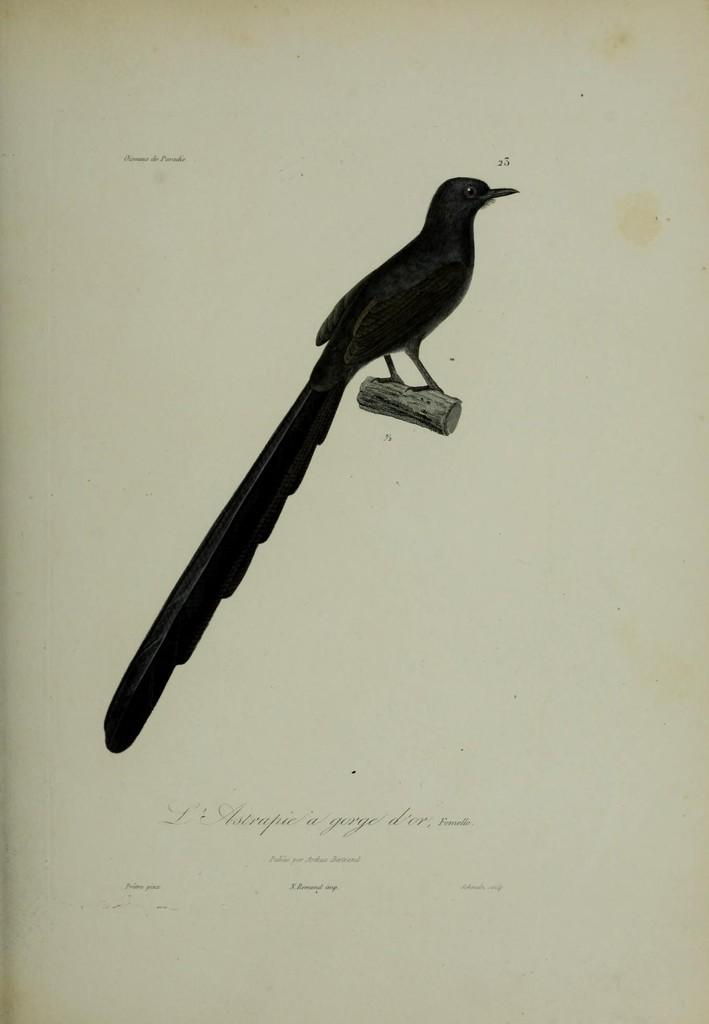What type of animal can be seen in the image? There is a bird in the image. Where is the bird located? The bird is on a wooden log. What else is present in the image besides the bird? There is there any text or writing? What type of plants can be seen growing on the bird in the image? There are no plants growing on the bird in the image. What shape is the bird in the image? The shape of the bird cannot be determined from the image alone, as it is a two-dimensional representation. How much friction is present between the bird and the wooden log in the image? The amount of friction between the bird and the wooden log cannot be determined from the image alone, as it is a static representation. 